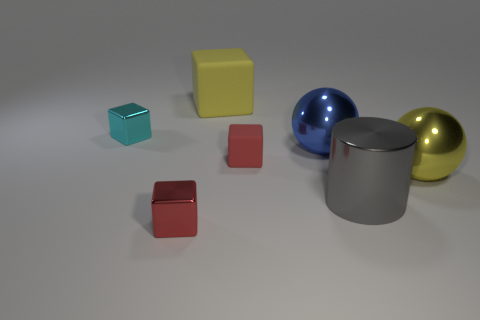Are there more spheres on the left side of the big yellow metal thing than big gray cylinders that are behind the large blue ball?
Your answer should be compact. Yes. How many matte objects are blue balls or large green cylinders?
Your answer should be very brief. 0. What shape is the large shiny object that is the same color as the large matte cube?
Offer a terse response. Sphere. What material is the yellow thing in front of the cyan metal object?
Give a very brief answer. Metal. How many things are either big metal objects or tiny objects that are left of the big yellow rubber cube?
Offer a terse response. 5. What shape is the metallic thing that is the same size as the red metal cube?
Offer a terse response. Cube. How many other metal cylinders are the same color as the large cylinder?
Your response must be concise. 0. Does the red thing that is to the right of the big matte thing have the same material as the small cyan thing?
Your response must be concise. No. The tiny red metal object has what shape?
Offer a terse response. Cube. How many purple things are large rubber spheres or tiny cubes?
Your answer should be very brief. 0. 